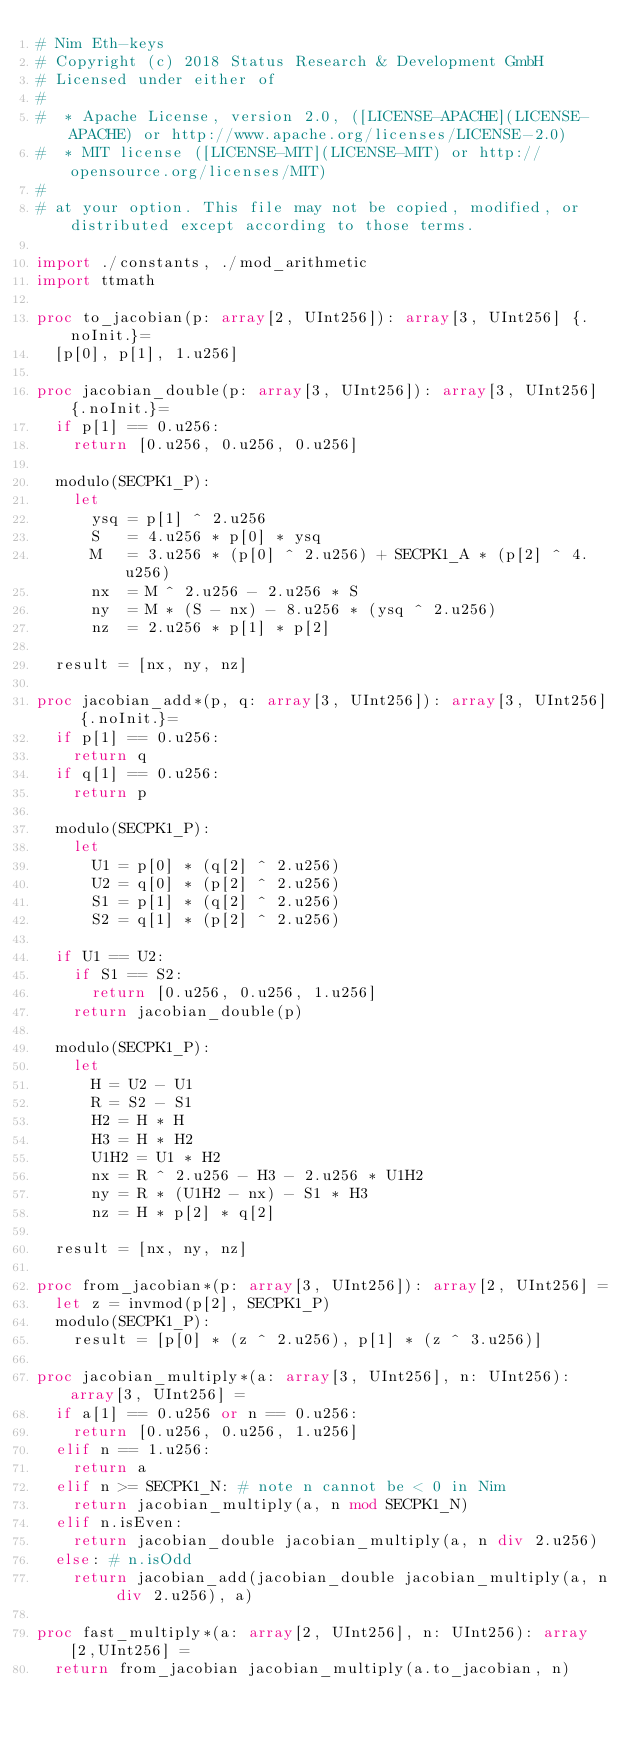Convert code to text. <code><loc_0><loc_0><loc_500><loc_500><_Nim_># Nim Eth-keys
# Copyright (c) 2018 Status Research & Development GmbH
# Licensed under either of
#
#  * Apache License, version 2.0, ([LICENSE-APACHE](LICENSE-APACHE) or http://www.apache.org/licenses/LICENSE-2.0)
#  * MIT license ([LICENSE-MIT](LICENSE-MIT) or http://opensource.org/licenses/MIT)
#
# at your option. This file may not be copied, modified, or distributed except according to those terms.

import ./constants, ./mod_arithmetic
import ttmath

proc to_jacobian(p: array[2, UInt256]): array[3, UInt256] {.noInit.}=
  [p[0], p[1], 1.u256]

proc jacobian_double(p: array[3, UInt256]): array[3, UInt256] {.noInit.}=
  if p[1] == 0.u256:
    return [0.u256, 0.u256, 0.u256]

  modulo(SECPK1_P):
    let
      ysq = p[1] ^ 2.u256
      S   = 4.u256 * p[0] * ysq
      M   = 3.u256 * (p[0] ^ 2.u256) + SECPK1_A * (p[2] ^ 4.u256)
      nx  = M ^ 2.u256 - 2.u256 * S
      ny  = M * (S - nx) - 8.u256 * (ysq ^ 2.u256)
      nz  = 2.u256 * p[1] * p[2]

  result = [nx, ny, nz]

proc jacobian_add*(p, q: array[3, UInt256]): array[3, UInt256] {.noInit.}=
  if p[1] == 0.u256:
    return q
  if q[1] == 0.u256:
    return p

  modulo(SECPK1_P):
    let
      U1 = p[0] * (q[2] ^ 2.u256)
      U2 = q[0] * (p[2] ^ 2.u256)
      S1 = p[1] * (q[2] ^ 2.u256)
      S2 = q[1] * (p[2] ^ 2.u256)

  if U1 == U2:
    if S1 == S2:
      return [0.u256, 0.u256, 1.u256]
    return jacobian_double(p)

  modulo(SECPK1_P):
    let
      H = U2 - U1
      R = S2 - S1
      H2 = H * H
      H3 = H * H2
      U1H2 = U1 * H2
      nx = R ^ 2.u256 - H3 - 2.u256 * U1H2
      ny = R * (U1H2 - nx) - S1 * H3
      nz = H * p[2] * q[2]

  result = [nx, ny, nz]

proc from_jacobian*(p: array[3, UInt256]): array[2, UInt256] =
  let z = invmod(p[2], SECPK1_P)
  modulo(SECPK1_P):
    result = [p[0] * (z ^ 2.u256), p[1] * (z ^ 3.u256)]

proc jacobian_multiply*(a: array[3, UInt256], n: UInt256): array[3, UInt256] =
  if a[1] == 0.u256 or n == 0.u256:
    return [0.u256, 0.u256, 1.u256]
  elif n == 1.u256:
    return a
  elif n >= SECPK1_N: # note n cannot be < 0 in Nim
    return jacobian_multiply(a, n mod SECPK1_N)
  elif n.isEven:
    return jacobian_double jacobian_multiply(a, n div 2.u256)
  else: # n.isOdd
    return jacobian_add(jacobian_double jacobian_multiply(a, n div 2.u256), a)

proc fast_multiply*(a: array[2, UInt256], n: UInt256): array[2,UInt256] =
  return from_jacobian jacobian_multiply(a.to_jacobian, n)
</code> 